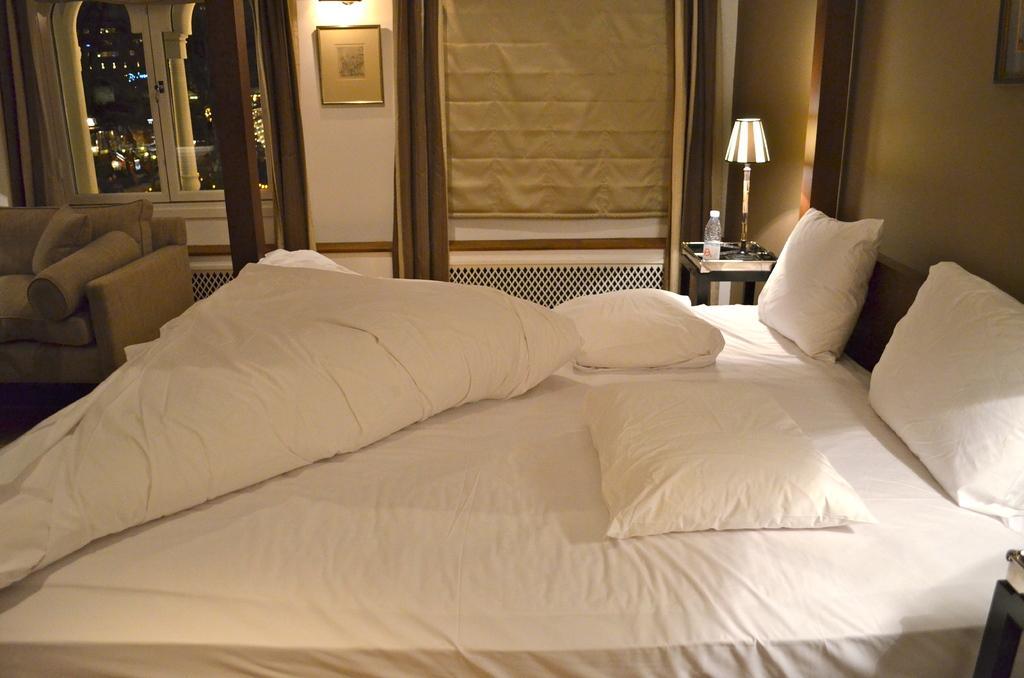Describe this image in one or two sentences. In this image i can see inside view of a room ,and there is a bed ,on the bed there are some pillows and back side of the bed there is a wall,beside it there a table , on the table there is a lamp and bottle. on the left side i can see a sofa set and there is a window and there is wall and a photo frame attached to the wall. 